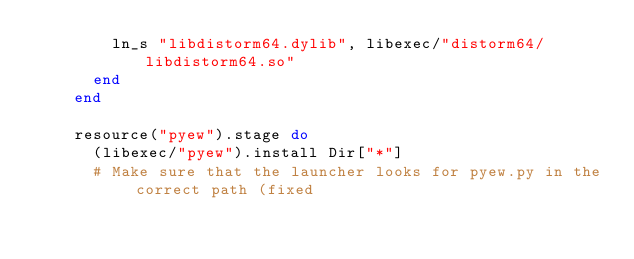Convert code to text. <code><loc_0><loc_0><loc_500><loc_500><_Ruby_>        ln_s "libdistorm64.dylib", libexec/"distorm64/libdistorm64.so"
      end
    end

    resource("pyew").stage do
      (libexec/"pyew").install Dir["*"]
      # Make sure that the launcher looks for pyew.py in the correct path (fixed</code> 